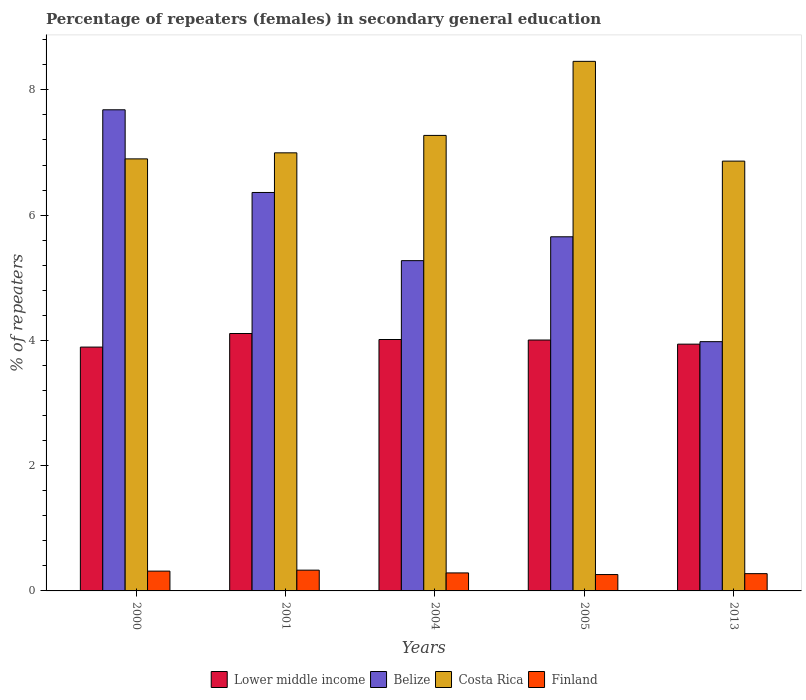How many different coloured bars are there?
Make the answer very short. 4. Are the number of bars per tick equal to the number of legend labels?
Keep it short and to the point. Yes. Are the number of bars on each tick of the X-axis equal?
Offer a terse response. Yes. What is the percentage of female repeaters in Belize in 2004?
Ensure brevity in your answer.  5.27. Across all years, what is the maximum percentage of female repeaters in Costa Rica?
Provide a succinct answer. 8.46. Across all years, what is the minimum percentage of female repeaters in Costa Rica?
Make the answer very short. 6.86. What is the total percentage of female repeaters in Belize in the graph?
Your response must be concise. 28.95. What is the difference between the percentage of female repeaters in Finland in 2000 and that in 2013?
Keep it short and to the point. 0.04. What is the difference between the percentage of female repeaters in Belize in 2000 and the percentage of female repeaters in Lower middle income in 2013?
Your answer should be compact. 3.74. What is the average percentage of female repeaters in Finland per year?
Provide a short and direct response. 0.29. In the year 2013, what is the difference between the percentage of female repeaters in Belize and percentage of female repeaters in Finland?
Your answer should be compact. 3.7. What is the ratio of the percentage of female repeaters in Finland in 2001 to that in 2004?
Provide a succinct answer. 1.15. Is the percentage of female repeaters in Finland in 2001 less than that in 2005?
Offer a very short reply. No. What is the difference between the highest and the second highest percentage of female repeaters in Costa Rica?
Offer a terse response. 1.18. What is the difference between the highest and the lowest percentage of female repeaters in Lower middle income?
Offer a very short reply. 0.22. In how many years, is the percentage of female repeaters in Belize greater than the average percentage of female repeaters in Belize taken over all years?
Your answer should be compact. 2. Is the sum of the percentage of female repeaters in Lower middle income in 2004 and 2013 greater than the maximum percentage of female repeaters in Costa Rica across all years?
Provide a succinct answer. No. Is it the case that in every year, the sum of the percentage of female repeaters in Finland and percentage of female repeaters in Costa Rica is greater than the sum of percentage of female repeaters in Belize and percentage of female repeaters in Lower middle income?
Ensure brevity in your answer.  Yes. What does the 1st bar from the left in 2005 represents?
Keep it short and to the point. Lower middle income. What does the 3rd bar from the right in 2000 represents?
Give a very brief answer. Belize. Is it the case that in every year, the sum of the percentage of female repeaters in Belize and percentage of female repeaters in Lower middle income is greater than the percentage of female repeaters in Costa Rica?
Make the answer very short. Yes. Are all the bars in the graph horizontal?
Provide a succinct answer. No. What is the difference between two consecutive major ticks on the Y-axis?
Your answer should be compact. 2. Does the graph contain any zero values?
Provide a short and direct response. No. Does the graph contain grids?
Your response must be concise. No. Where does the legend appear in the graph?
Your response must be concise. Bottom center. How many legend labels are there?
Your answer should be very brief. 4. How are the legend labels stacked?
Your answer should be very brief. Horizontal. What is the title of the graph?
Ensure brevity in your answer.  Percentage of repeaters (females) in secondary general education. What is the label or title of the X-axis?
Offer a very short reply. Years. What is the label or title of the Y-axis?
Keep it short and to the point. % of repeaters. What is the % of repeaters of Lower middle income in 2000?
Your answer should be compact. 3.89. What is the % of repeaters of Belize in 2000?
Your response must be concise. 7.68. What is the % of repeaters in Costa Rica in 2000?
Offer a very short reply. 6.9. What is the % of repeaters of Finland in 2000?
Offer a very short reply. 0.32. What is the % of repeaters in Lower middle income in 2001?
Give a very brief answer. 4.11. What is the % of repeaters in Belize in 2001?
Make the answer very short. 6.36. What is the % of repeaters in Costa Rica in 2001?
Keep it short and to the point. 6.99. What is the % of repeaters in Finland in 2001?
Provide a short and direct response. 0.33. What is the % of repeaters of Lower middle income in 2004?
Provide a short and direct response. 4.01. What is the % of repeaters in Belize in 2004?
Your answer should be compact. 5.27. What is the % of repeaters in Costa Rica in 2004?
Ensure brevity in your answer.  7.27. What is the % of repeaters of Finland in 2004?
Your answer should be compact. 0.29. What is the % of repeaters in Lower middle income in 2005?
Ensure brevity in your answer.  4.01. What is the % of repeaters of Belize in 2005?
Your answer should be very brief. 5.65. What is the % of repeaters of Costa Rica in 2005?
Offer a terse response. 8.46. What is the % of repeaters of Finland in 2005?
Make the answer very short. 0.26. What is the % of repeaters of Lower middle income in 2013?
Your answer should be compact. 3.94. What is the % of repeaters in Belize in 2013?
Ensure brevity in your answer.  3.98. What is the % of repeaters in Costa Rica in 2013?
Provide a succinct answer. 6.86. What is the % of repeaters of Finland in 2013?
Your answer should be very brief. 0.28. Across all years, what is the maximum % of repeaters of Lower middle income?
Offer a terse response. 4.11. Across all years, what is the maximum % of repeaters of Belize?
Offer a very short reply. 7.68. Across all years, what is the maximum % of repeaters in Costa Rica?
Keep it short and to the point. 8.46. Across all years, what is the maximum % of repeaters in Finland?
Your answer should be very brief. 0.33. Across all years, what is the minimum % of repeaters in Lower middle income?
Make the answer very short. 3.89. Across all years, what is the minimum % of repeaters of Belize?
Make the answer very short. 3.98. Across all years, what is the minimum % of repeaters of Costa Rica?
Provide a short and direct response. 6.86. Across all years, what is the minimum % of repeaters in Finland?
Your answer should be very brief. 0.26. What is the total % of repeaters in Lower middle income in the graph?
Provide a succinct answer. 19.96. What is the total % of repeaters in Belize in the graph?
Make the answer very short. 28.95. What is the total % of repeaters in Costa Rica in the graph?
Give a very brief answer. 36.48. What is the total % of repeaters of Finland in the graph?
Offer a terse response. 1.47. What is the difference between the % of repeaters of Lower middle income in 2000 and that in 2001?
Provide a succinct answer. -0.22. What is the difference between the % of repeaters of Belize in 2000 and that in 2001?
Provide a short and direct response. 1.32. What is the difference between the % of repeaters of Costa Rica in 2000 and that in 2001?
Your response must be concise. -0.1. What is the difference between the % of repeaters of Finland in 2000 and that in 2001?
Offer a very short reply. -0.02. What is the difference between the % of repeaters in Lower middle income in 2000 and that in 2004?
Make the answer very short. -0.12. What is the difference between the % of repeaters of Belize in 2000 and that in 2004?
Give a very brief answer. 2.41. What is the difference between the % of repeaters of Costa Rica in 2000 and that in 2004?
Keep it short and to the point. -0.37. What is the difference between the % of repeaters of Finland in 2000 and that in 2004?
Your answer should be very brief. 0.03. What is the difference between the % of repeaters in Lower middle income in 2000 and that in 2005?
Give a very brief answer. -0.11. What is the difference between the % of repeaters of Belize in 2000 and that in 2005?
Give a very brief answer. 2.03. What is the difference between the % of repeaters of Costa Rica in 2000 and that in 2005?
Your response must be concise. -1.56. What is the difference between the % of repeaters in Finland in 2000 and that in 2005?
Ensure brevity in your answer.  0.06. What is the difference between the % of repeaters in Lower middle income in 2000 and that in 2013?
Ensure brevity in your answer.  -0.05. What is the difference between the % of repeaters of Belize in 2000 and that in 2013?
Give a very brief answer. 3.7. What is the difference between the % of repeaters in Costa Rica in 2000 and that in 2013?
Provide a short and direct response. 0.04. What is the difference between the % of repeaters in Finland in 2000 and that in 2013?
Give a very brief answer. 0.04. What is the difference between the % of repeaters of Lower middle income in 2001 and that in 2004?
Make the answer very short. 0.1. What is the difference between the % of repeaters in Belize in 2001 and that in 2004?
Your answer should be very brief. 1.09. What is the difference between the % of repeaters of Costa Rica in 2001 and that in 2004?
Give a very brief answer. -0.28. What is the difference between the % of repeaters of Finland in 2001 and that in 2004?
Keep it short and to the point. 0.04. What is the difference between the % of repeaters of Lower middle income in 2001 and that in 2005?
Your response must be concise. 0.1. What is the difference between the % of repeaters of Belize in 2001 and that in 2005?
Ensure brevity in your answer.  0.71. What is the difference between the % of repeaters in Costa Rica in 2001 and that in 2005?
Keep it short and to the point. -1.46. What is the difference between the % of repeaters in Finland in 2001 and that in 2005?
Keep it short and to the point. 0.07. What is the difference between the % of repeaters in Lower middle income in 2001 and that in 2013?
Give a very brief answer. 0.17. What is the difference between the % of repeaters of Belize in 2001 and that in 2013?
Provide a succinct answer. 2.38. What is the difference between the % of repeaters of Costa Rica in 2001 and that in 2013?
Your response must be concise. 0.13. What is the difference between the % of repeaters in Finland in 2001 and that in 2013?
Make the answer very short. 0.06. What is the difference between the % of repeaters of Lower middle income in 2004 and that in 2005?
Provide a short and direct response. 0.01. What is the difference between the % of repeaters in Belize in 2004 and that in 2005?
Provide a short and direct response. -0.38. What is the difference between the % of repeaters of Costa Rica in 2004 and that in 2005?
Offer a terse response. -1.18. What is the difference between the % of repeaters of Finland in 2004 and that in 2005?
Your answer should be very brief. 0.03. What is the difference between the % of repeaters in Lower middle income in 2004 and that in 2013?
Provide a succinct answer. 0.07. What is the difference between the % of repeaters of Belize in 2004 and that in 2013?
Your response must be concise. 1.29. What is the difference between the % of repeaters in Costa Rica in 2004 and that in 2013?
Provide a short and direct response. 0.41. What is the difference between the % of repeaters in Finland in 2004 and that in 2013?
Offer a very short reply. 0.01. What is the difference between the % of repeaters in Lower middle income in 2005 and that in 2013?
Your answer should be compact. 0.07. What is the difference between the % of repeaters in Belize in 2005 and that in 2013?
Give a very brief answer. 1.67. What is the difference between the % of repeaters in Costa Rica in 2005 and that in 2013?
Offer a terse response. 1.59. What is the difference between the % of repeaters in Finland in 2005 and that in 2013?
Ensure brevity in your answer.  -0.01. What is the difference between the % of repeaters in Lower middle income in 2000 and the % of repeaters in Belize in 2001?
Keep it short and to the point. -2.47. What is the difference between the % of repeaters of Lower middle income in 2000 and the % of repeaters of Costa Rica in 2001?
Your response must be concise. -3.1. What is the difference between the % of repeaters of Lower middle income in 2000 and the % of repeaters of Finland in 2001?
Ensure brevity in your answer.  3.56. What is the difference between the % of repeaters of Belize in 2000 and the % of repeaters of Costa Rica in 2001?
Ensure brevity in your answer.  0.69. What is the difference between the % of repeaters in Belize in 2000 and the % of repeaters in Finland in 2001?
Offer a terse response. 7.35. What is the difference between the % of repeaters of Costa Rica in 2000 and the % of repeaters of Finland in 2001?
Make the answer very short. 6.57. What is the difference between the % of repeaters in Lower middle income in 2000 and the % of repeaters in Belize in 2004?
Give a very brief answer. -1.38. What is the difference between the % of repeaters of Lower middle income in 2000 and the % of repeaters of Costa Rica in 2004?
Provide a short and direct response. -3.38. What is the difference between the % of repeaters of Lower middle income in 2000 and the % of repeaters of Finland in 2004?
Your response must be concise. 3.61. What is the difference between the % of repeaters of Belize in 2000 and the % of repeaters of Costa Rica in 2004?
Make the answer very short. 0.41. What is the difference between the % of repeaters in Belize in 2000 and the % of repeaters in Finland in 2004?
Keep it short and to the point. 7.39. What is the difference between the % of repeaters in Costa Rica in 2000 and the % of repeaters in Finland in 2004?
Your answer should be compact. 6.61. What is the difference between the % of repeaters in Lower middle income in 2000 and the % of repeaters in Belize in 2005?
Give a very brief answer. -1.76. What is the difference between the % of repeaters in Lower middle income in 2000 and the % of repeaters in Costa Rica in 2005?
Ensure brevity in your answer.  -4.56. What is the difference between the % of repeaters of Lower middle income in 2000 and the % of repeaters of Finland in 2005?
Provide a short and direct response. 3.63. What is the difference between the % of repeaters in Belize in 2000 and the % of repeaters in Costa Rica in 2005?
Make the answer very short. -0.77. What is the difference between the % of repeaters of Belize in 2000 and the % of repeaters of Finland in 2005?
Give a very brief answer. 7.42. What is the difference between the % of repeaters of Costa Rica in 2000 and the % of repeaters of Finland in 2005?
Provide a short and direct response. 6.64. What is the difference between the % of repeaters of Lower middle income in 2000 and the % of repeaters of Belize in 2013?
Offer a terse response. -0.09. What is the difference between the % of repeaters of Lower middle income in 2000 and the % of repeaters of Costa Rica in 2013?
Provide a short and direct response. -2.97. What is the difference between the % of repeaters in Lower middle income in 2000 and the % of repeaters in Finland in 2013?
Keep it short and to the point. 3.62. What is the difference between the % of repeaters of Belize in 2000 and the % of repeaters of Costa Rica in 2013?
Keep it short and to the point. 0.82. What is the difference between the % of repeaters of Belize in 2000 and the % of repeaters of Finland in 2013?
Give a very brief answer. 7.41. What is the difference between the % of repeaters in Costa Rica in 2000 and the % of repeaters in Finland in 2013?
Give a very brief answer. 6.62. What is the difference between the % of repeaters in Lower middle income in 2001 and the % of repeaters in Belize in 2004?
Ensure brevity in your answer.  -1.16. What is the difference between the % of repeaters of Lower middle income in 2001 and the % of repeaters of Costa Rica in 2004?
Provide a succinct answer. -3.16. What is the difference between the % of repeaters of Lower middle income in 2001 and the % of repeaters of Finland in 2004?
Make the answer very short. 3.82. What is the difference between the % of repeaters in Belize in 2001 and the % of repeaters in Costa Rica in 2004?
Your response must be concise. -0.91. What is the difference between the % of repeaters in Belize in 2001 and the % of repeaters in Finland in 2004?
Give a very brief answer. 6.07. What is the difference between the % of repeaters of Costa Rica in 2001 and the % of repeaters of Finland in 2004?
Your response must be concise. 6.71. What is the difference between the % of repeaters of Lower middle income in 2001 and the % of repeaters of Belize in 2005?
Offer a very short reply. -1.54. What is the difference between the % of repeaters in Lower middle income in 2001 and the % of repeaters in Costa Rica in 2005?
Your answer should be very brief. -4.35. What is the difference between the % of repeaters in Lower middle income in 2001 and the % of repeaters in Finland in 2005?
Offer a very short reply. 3.85. What is the difference between the % of repeaters of Belize in 2001 and the % of repeaters of Costa Rica in 2005?
Offer a terse response. -2.09. What is the difference between the % of repeaters of Belize in 2001 and the % of repeaters of Finland in 2005?
Provide a short and direct response. 6.1. What is the difference between the % of repeaters of Costa Rica in 2001 and the % of repeaters of Finland in 2005?
Ensure brevity in your answer.  6.73. What is the difference between the % of repeaters in Lower middle income in 2001 and the % of repeaters in Belize in 2013?
Provide a short and direct response. 0.13. What is the difference between the % of repeaters in Lower middle income in 2001 and the % of repeaters in Costa Rica in 2013?
Offer a very short reply. -2.75. What is the difference between the % of repeaters of Lower middle income in 2001 and the % of repeaters of Finland in 2013?
Keep it short and to the point. 3.83. What is the difference between the % of repeaters in Belize in 2001 and the % of repeaters in Costa Rica in 2013?
Provide a short and direct response. -0.5. What is the difference between the % of repeaters in Belize in 2001 and the % of repeaters in Finland in 2013?
Provide a short and direct response. 6.09. What is the difference between the % of repeaters in Costa Rica in 2001 and the % of repeaters in Finland in 2013?
Provide a short and direct response. 6.72. What is the difference between the % of repeaters in Lower middle income in 2004 and the % of repeaters in Belize in 2005?
Keep it short and to the point. -1.64. What is the difference between the % of repeaters in Lower middle income in 2004 and the % of repeaters in Costa Rica in 2005?
Your response must be concise. -4.44. What is the difference between the % of repeaters of Lower middle income in 2004 and the % of repeaters of Finland in 2005?
Your answer should be compact. 3.75. What is the difference between the % of repeaters of Belize in 2004 and the % of repeaters of Costa Rica in 2005?
Ensure brevity in your answer.  -3.18. What is the difference between the % of repeaters of Belize in 2004 and the % of repeaters of Finland in 2005?
Keep it short and to the point. 5.01. What is the difference between the % of repeaters in Costa Rica in 2004 and the % of repeaters in Finland in 2005?
Make the answer very short. 7.01. What is the difference between the % of repeaters of Lower middle income in 2004 and the % of repeaters of Belize in 2013?
Ensure brevity in your answer.  0.03. What is the difference between the % of repeaters in Lower middle income in 2004 and the % of repeaters in Costa Rica in 2013?
Offer a very short reply. -2.85. What is the difference between the % of repeaters in Lower middle income in 2004 and the % of repeaters in Finland in 2013?
Your answer should be compact. 3.74. What is the difference between the % of repeaters of Belize in 2004 and the % of repeaters of Costa Rica in 2013?
Your answer should be compact. -1.59. What is the difference between the % of repeaters of Belize in 2004 and the % of repeaters of Finland in 2013?
Provide a short and direct response. 5. What is the difference between the % of repeaters of Costa Rica in 2004 and the % of repeaters of Finland in 2013?
Give a very brief answer. 7. What is the difference between the % of repeaters in Lower middle income in 2005 and the % of repeaters in Belize in 2013?
Ensure brevity in your answer.  0.03. What is the difference between the % of repeaters of Lower middle income in 2005 and the % of repeaters of Costa Rica in 2013?
Ensure brevity in your answer.  -2.86. What is the difference between the % of repeaters of Lower middle income in 2005 and the % of repeaters of Finland in 2013?
Offer a terse response. 3.73. What is the difference between the % of repeaters of Belize in 2005 and the % of repeaters of Costa Rica in 2013?
Give a very brief answer. -1.21. What is the difference between the % of repeaters in Belize in 2005 and the % of repeaters in Finland in 2013?
Offer a terse response. 5.38. What is the difference between the % of repeaters of Costa Rica in 2005 and the % of repeaters of Finland in 2013?
Offer a very short reply. 8.18. What is the average % of repeaters of Lower middle income per year?
Give a very brief answer. 3.99. What is the average % of repeaters in Belize per year?
Offer a terse response. 5.79. What is the average % of repeaters of Costa Rica per year?
Offer a very short reply. 7.3. What is the average % of repeaters of Finland per year?
Make the answer very short. 0.29. In the year 2000, what is the difference between the % of repeaters of Lower middle income and % of repeaters of Belize?
Make the answer very short. -3.79. In the year 2000, what is the difference between the % of repeaters in Lower middle income and % of repeaters in Costa Rica?
Give a very brief answer. -3. In the year 2000, what is the difference between the % of repeaters of Lower middle income and % of repeaters of Finland?
Offer a very short reply. 3.58. In the year 2000, what is the difference between the % of repeaters in Belize and % of repeaters in Costa Rica?
Make the answer very short. 0.78. In the year 2000, what is the difference between the % of repeaters of Belize and % of repeaters of Finland?
Offer a terse response. 7.37. In the year 2000, what is the difference between the % of repeaters of Costa Rica and % of repeaters of Finland?
Ensure brevity in your answer.  6.58. In the year 2001, what is the difference between the % of repeaters of Lower middle income and % of repeaters of Belize?
Make the answer very short. -2.25. In the year 2001, what is the difference between the % of repeaters of Lower middle income and % of repeaters of Costa Rica?
Give a very brief answer. -2.88. In the year 2001, what is the difference between the % of repeaters of Lower middle income and % of repeaters of Finland?
Offer a very short reply. 3.78. In the year 2001, what is the difference between the % of repeaters of Belize and % of repeaters of Costa Rica?
Give a very brief answer. -0.63. In the year 2001, what is the difference between the % of repeaters in Belize and % of repeaters in Finland?
Keep it short and to the point. 6.03. In the year 2001, what is the difference between the % of repeaters in Costa Rica and % of repeaters in Finland?
Your response must be concise. 6.66. In the year 2004, what is the difference between the % of repeaters in Lower middle income and % of repeaters in Belize?
Keep it short and to the point. -1.26. In the year 2004, what is the difference between the % of repeaters of Lower middle income and % of repeaters of Costa Rica?
Your response must be concise. -3.26. In the year 2004, what is the difference between the % of repeaters in Lower middle income and % of repeaters in Finland?
Make the answer very short. 3.73. In the year 2004, what is the difference between the % of repeaters in Belize and % of repeaters in Costa Rica?
Provide a short and direct response. -2. In the year 2004, what is the difference between the % of repeaters of Belize and % of repeaters of Finland?
Give a very brief answer. 4.99. In the year 2004, what is the difference between the % of repeaters in Costa Rica and % of repeaters in Finland?
Offer a terse response. 6.99. In the year 2005, what is the difference between the % of repeaters of Lower middle income and % of repeaters of Belize?
Give a very brief answer. -1.65. In the year 2005, what is the difference between the % of repeaters of Lower middle income and % of repeaters of Costa Rica?
Your answer should be very brief. -4.45. In the year 2005, what is the difference between the % of repeaters of Lower middle income and % of repeaters of Finland?
Give a very brief answer. 3.74. In the year 2005, what is the difference between the % of repeaters of Belize and % of repeaters of Costa Rica?
Offer a terse response. -2.8. In the year 2005, what is the difference between the % of repeaters of Belize and % of repeaters of Finland?
Your answer should be very brief. 5.39. In the year 2005, what is the difference between the % of repeaters of Costa Rica and % of repeaters of Finland?
Offer a terse response. 8.19. In the year 2013, what is the difference between the % of repeaters in Lower middle income and % of repeaters in Belize?
Offer a very short reply. -0.04. In the year 2013, what is the difference between the % of repeaters of Lower middle income and % of repeaters of Costa Rica?
Keep it short and to the point. -2.92. In the year 2013, what is the difference between the % of repeaters in Lower middle income and % of repeaters in Finland?
Offer a terse response. 3.66. In the year 2013, what is the difference between the % of repeaters in Belize and % of repeaters in Costa Rica?
Keep it short and to the point. -2.88. In the year 2013, what is the difference between the % of repeaters in Belize and % of repeaters in Finland?
Your response must be concise. 3.7. In the year 2013, what is the difference between the % of repeaters in Costa Rica and % of repeaters in Finland?
Make the answer very short. 6.59. What is the ratio of the % of repeaters of Lower middle income in 2000 to that in 2001?
Your answer should be very brief. 0.95. What is the ratio of the % of repeaters in Belize in 2000 to that in 2001?
Ensure brevity in your answer.  1.21. What is the ratio of the % of repeaters in Costa Rica in 2000 to that in 2001?
Your response must be concise. 0.99. What is the ratio of the % of repeaters in Finland in 2000 to that in 2001?
Offer a very short reply. 0.95. What is the ratio of the % of repeaters in Lower middle income in 2000 to that in 2004?
Give a very brief answer. 0.97. What is the ratio of the % of repeaters in Belize in 2000 to that in 2004?
Provide a succinct answer. 1.46. What is the ratio of the % of repeaters of Costa Rica in 2000 to that in 2004?
Your answer should be very brief. 0.95. What is the ratio of the % of repeaters in Finland in 2000 to that in 2004?
Keep it short and to the point. 1.1. What is the ratio of the % of repeaters in Lower middle income in 2000 to that in 2005?
Offer a terse response. 0.97. What is the ratio of the % of repeaters in Belize in 2000 to that in 2005?
Provide a succinct answer. 1.36. What is the ratio of the % of repeaters of Costa Rica in 2000 to that in 2005?
Your response must be concise. 0.82. What is the ratio of the % of repeaters in Finland in 2000 to that in 2005?
Offer a terse response. 1.21. What is the ratio of the % of repeaters of Lower middle income in 2000 to that in 2013?
Provide a succinct answer. 0.99. What is the ratio of the % of repeaters in Belize in 2000 to that in 2013?
Offer a very short reply. 1.93. What is the ratio of the % of repeaters of Costa Rica in 2000 to that in 2013?
Keep it short and to the point. 1.01. What is the ratio of the % of repeaters of Finland in 2000 to that in 2013?
Provide a short and direct response. 1.15. What is the ratio of the % of repeaters of Lower middle income in 2001 to that in 2004?
Your answer should be very brief. 1.02. What is the ratio of the % of repeaters of Belize in 2001 to that in 2004?
Provide a succinct answer. 1.21. What is the ratio of the % of repeaters in Costa Rica in 2001 to that in 2004?
Provide a short and direct response. 0.96. What is the ratio of the % of repeaters of Finland in 2001 to that in 2004?
Offer a terse response. 1.15. What is the ratio of the % of repeaters of Lower middle income in 2001 to that in 2005?
Provide a short and direct response. 1.03. What is the ratio of the % of repeaters of Belize in 2001 to that in 2005?
Provide a short and direct response. 1.13. What is the ratio of the % of repeaters of Costa Rica in 2001 to that in 2005?
Ensure brevity in your answer.  0.83. What is the ratio of the % of repeaters in Finland in 2001 to that in 2005?
Your response must be concise. 1.27. What is the ratio of the % of repeaters in Lower middle income in 2001 to that in 2013?
Keep it short and to the point. 1.04. What is the ratio of the % of repeaters in Belize in 2001 to that in 2013?
Offer a very short reply. 1.6. What is the ratio of the % of repeaters in Costa Rica in 2001 to that in 2013?
Your answer should be compact. 1.02. What is the ratio of the % of repeaters of Finland in 2001 to that in 2013?
Offer a very short reply. 1.2. What is the ratio of the % of repeaters of Belize in 2004 to that in 2005?
Give a very brief answer. 0.93. What is the ratio of the % of repeaters in Costa Rica in 2004 to that in 2005?
Your answer should be very brief. 0.86. What is the ratio of the % of repeaters of Finland in 2004 to that in 2005?
Offer a very short reply. 1.1. What is the ratio of the % of repeaters of Lower middle income in 2004 to that in 2013?
Keep it short and to the point. 1.02. What is the ratio of the % of repeaters in Belize in 2004 to that in 2013?
Your response must be concise. 1.32. What is the ratio of the % of repeaters of Costa Rica in 2004 to that in 2013?
Make the answer very short. 1.06. What is the ratio of the % of repeaters in Finland in 2004 to that in 2013?
Provide a short and direct response. 1.04. What is the ratio of the % of repeaters of Lower middle income in 2005 to that in 2013?
Your answer should be very brief. 1.02. What is the ratio of the % of repeaters of Belize in 2005 to that in 2013?
Your response must be concise. 1.42. What is the ratio of the % of repeaters in Costa Rica in 2005 to that in 2013?
Your response must be concise. 1.23. What is the ratio of the % of repeaters of Finland in 2005 to that in 2013?
Provide a short and direct response. 0.95. What is the difference between the highest and the second highest % of repeaters in Lower middle income?
Provide a succinct answer. 0.1. What is the difference between the highest and the second highest % of repeaters of Belize?
Provide a succinct answer. 1.32. What is the difference between the highest and the second highest % of repeaters of Costa Rica?
Provide a short and direct response. 1.18. What is the difference between the highest and the second highest % of repeaters in Finland?
Offer a very short reply. 0.02. What is the difference between the highest and the lowest % of repeaters in Lower middle income?
Provide a succinct answer. 0.22. What is the difference between the highest and the lowest % of repeaters in Belize?
Keep it short and to the point. 3.7. What is the difference between the highest and the lowest % of repeaters of Costa Rica?
Offer a terse response. 1.59. What is the difference between the highest and the lowest % of repeaters of Finland?
Your answer should be compact. 0.07. 